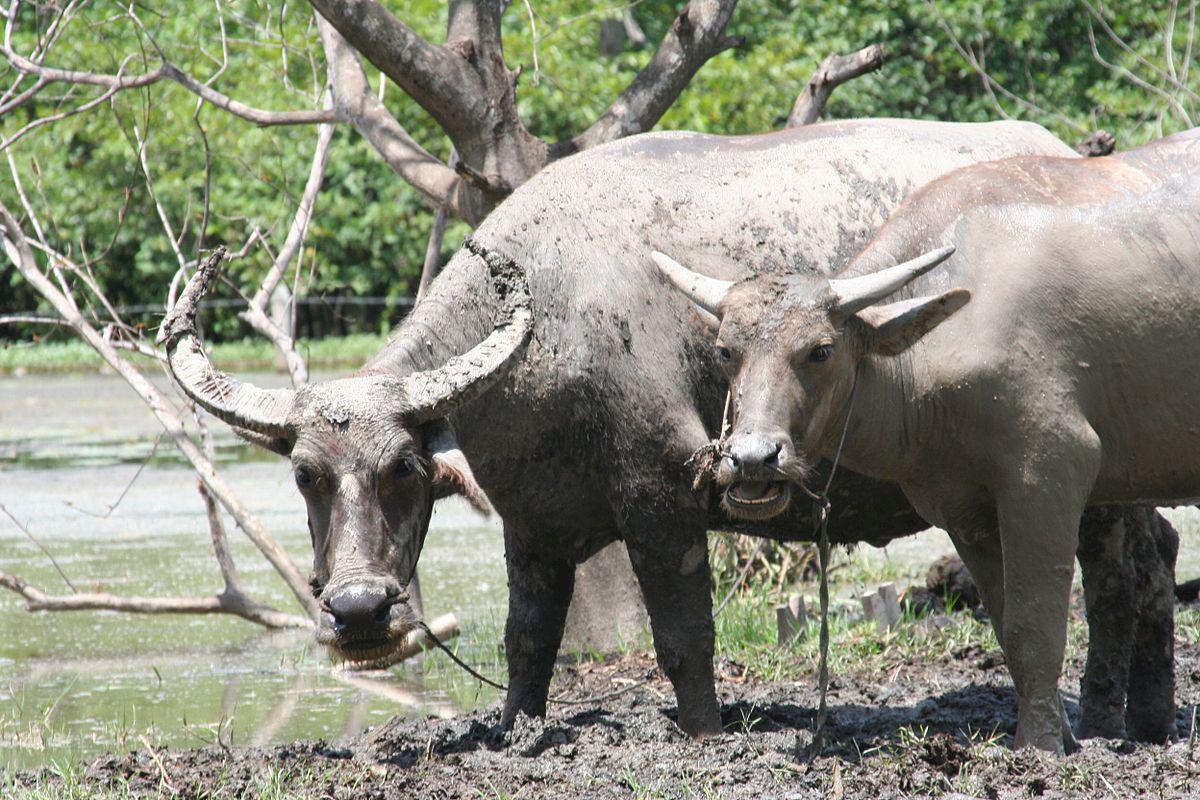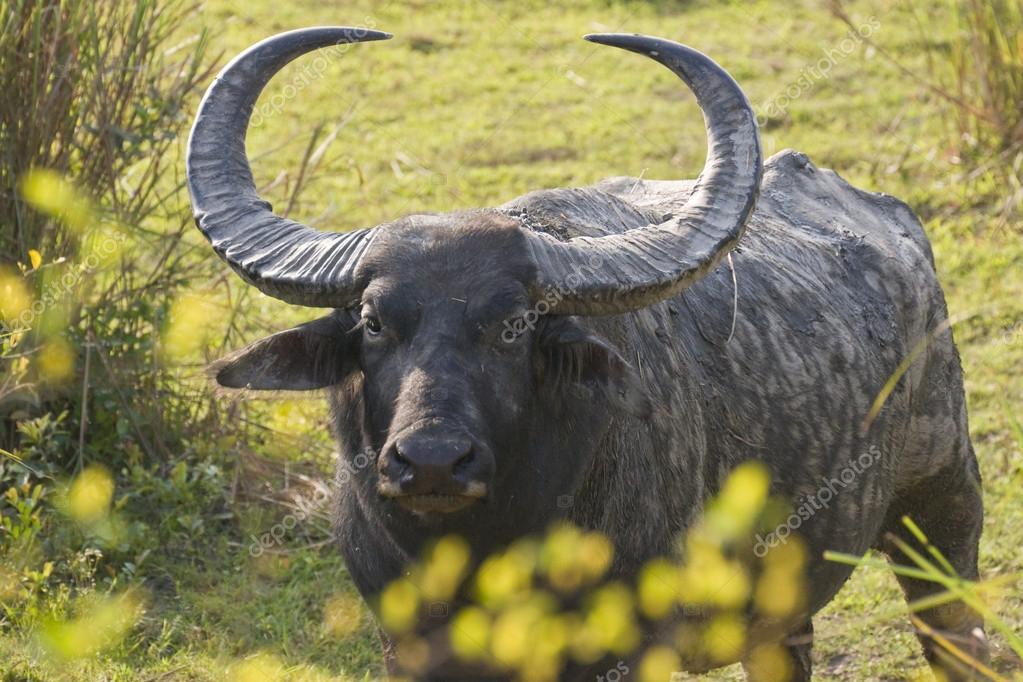The first image is the image on the left, the second image is the image on the right. Analyze the images presented: Is the assertion "The cow in the image on the right is near a watery area." valid? Answer yes or no. No. The first image is the image on the left, the second image is the image on the right. Evaluate the accuracy of this statement regarding the images: "An image shows at least one forward-looking ox with a rope threaded through its nose, standing in a wet, muddy area.". Is it true? Answer yes or no. Yes. 